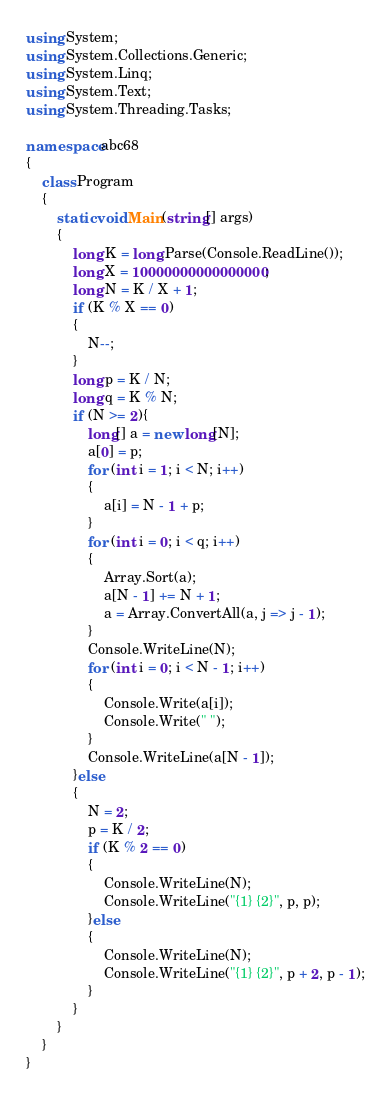<code> <loc_0><loc_0><loc_500><loc_500><_C#_>using System;
using System.Collections.Generic;
using System.Linq;
using System.Text;
using System.Threading.Tasks;

namespace abc68
{
    class Program
    {
        static void Main(string[] args)
        {
            long K = long.Parse(Console.ReadLine());
            long X = 10000000000000000;
            long N = K / X + 1;
            if (K % X == 0)
            {
                N--;
            }
            long p = K / N;
            long q = K % N;
            if (N >= 2){
                long[] a = new long[N];
                a[0] = p;
                for (int i = 1; i < N; i++)
                {
                    a[i] = N - 1 + p;
                }
                for (int i = 0; i < q; i++)
                {
                    Array.Sort(a);
                    a[N - 1] += N + 1;
                    a = Array.ConvertAll(a, j => j - 1);
                }
                Console.WriteLine(N);
                for (int i = 0; i < N - 1; i++)
                {
                    Console.Write(a[i]);
                    Console.Write(" ");
                }
                Console.WriteLine(a[N - 1]);
            }else
            {
                N = 2;
                p = K / 2;
                if (K % 2 == 0)
                {          
                    Console.WriteLine(N);
                    Console.WriteLine("{1} {2}", p, p);
                }else
                {
                    Console.WriteLine(N);
                    Console.WriteLine("{1} {2}", p + 2, p - 1);
                }
            }
        }
    }
}
</code> 